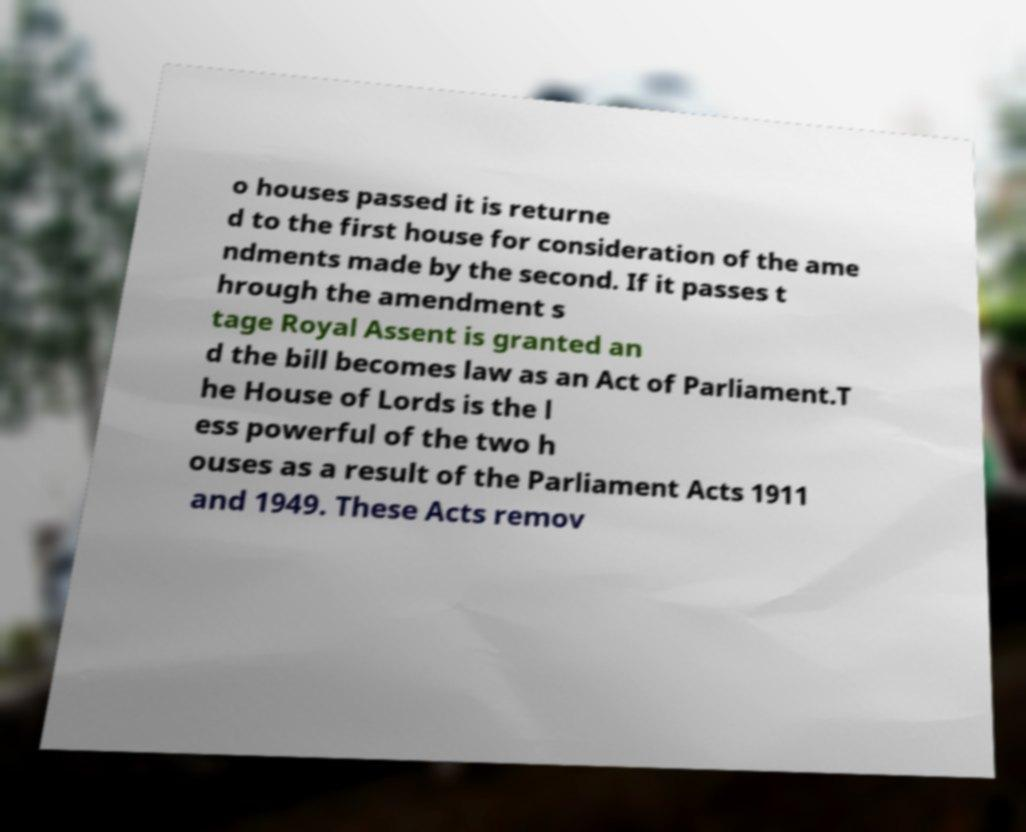Could you extract and type out the text from this image? o houses passed it is returne d to the first house for consideration of the ame ndments made by the second. If it passes t hrough the amendment s tage Royal Assent is granted an d the bill becomes law as an Act of Parliament.T he House of Lords is the l ess powerful of the two h ouses as a result of the Parliament Acts 1911 and 1949. These Acts remov 